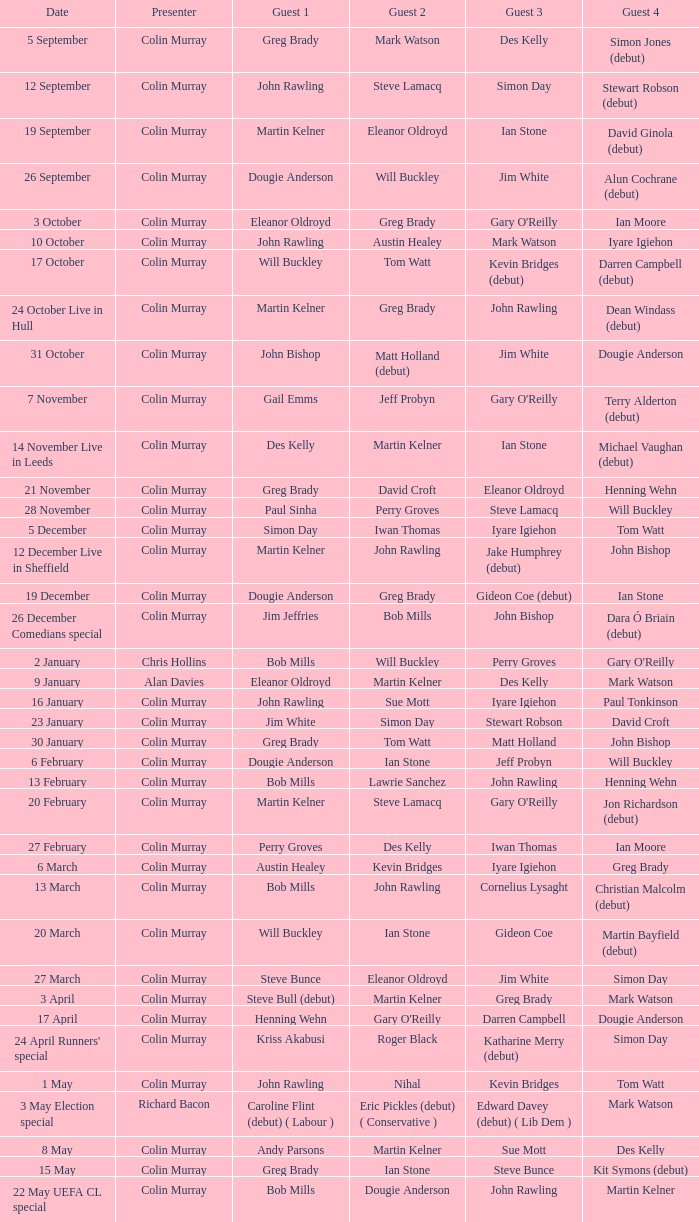When des kelly is the fourth guest, how many different people have taken the role of guest 1? 1.0. 